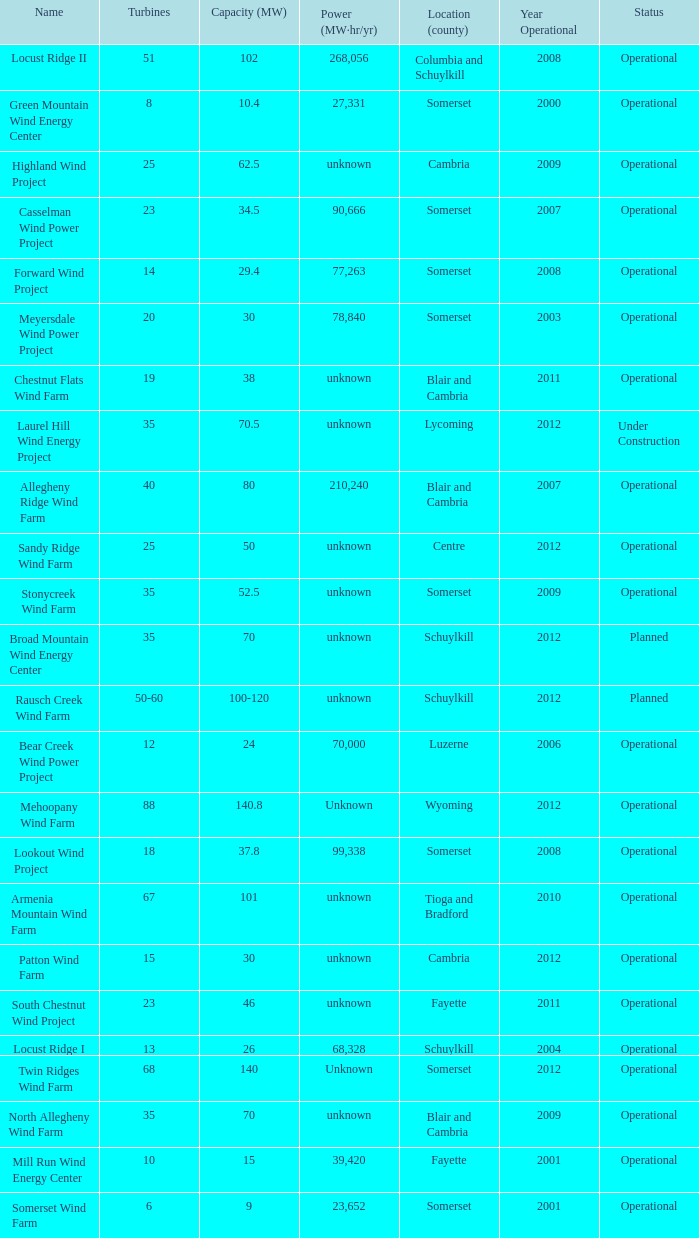What all capacities have turbines between 50-60? 100-120. 